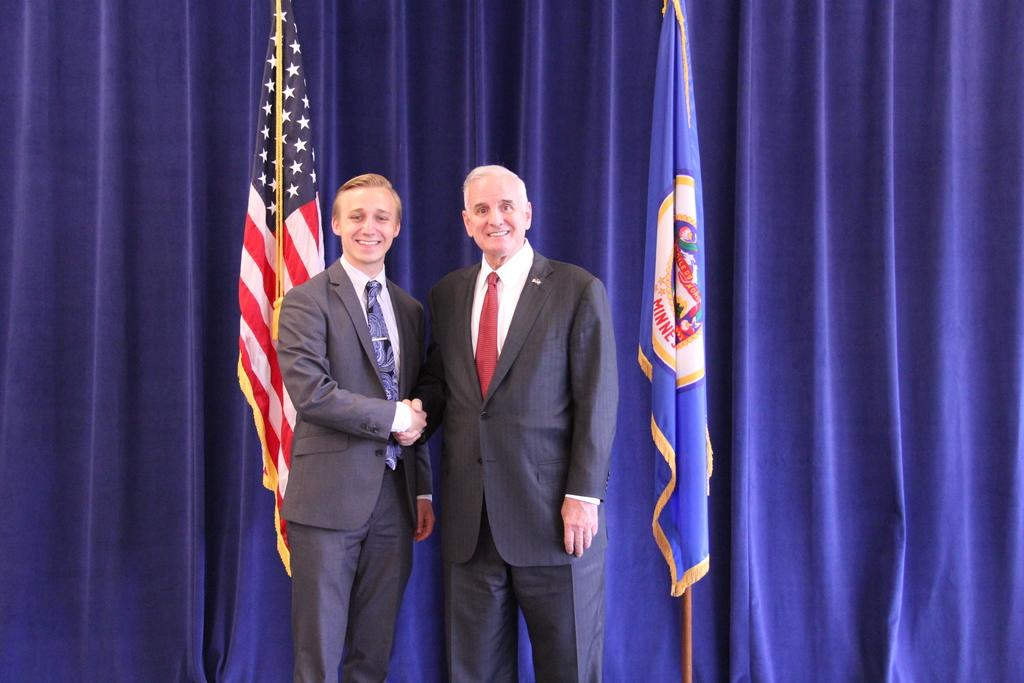What is the main subject of the image? There is a person standing in the center of the image. What is the person's position in relation to the ground? The person is standing on the floor. What can be seen in the background of the image? There are flags and a curtain in the background of the image. What is the value of the person's skin in the image? There is no indication of the person's skin value in the image, as this concept is not relevant to the image's content. 